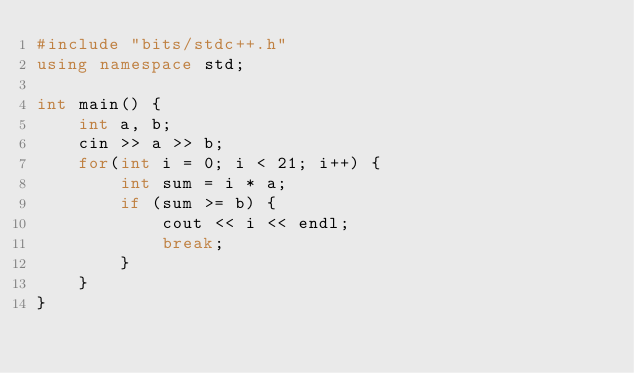Convert code to text. <code><loc_0><loc_0><loc_500><loc_500><_C++_>#include "bits/stdc++.h"
using namespace std;

int main() {
	int a, b;
	cin >> a >> b;
	for(int i = 0; i < 21; i++) {
		int sum = i * a;
		if (sum >= b) {
			cout << i << endl;
			break;
		}
	}
}</code> 